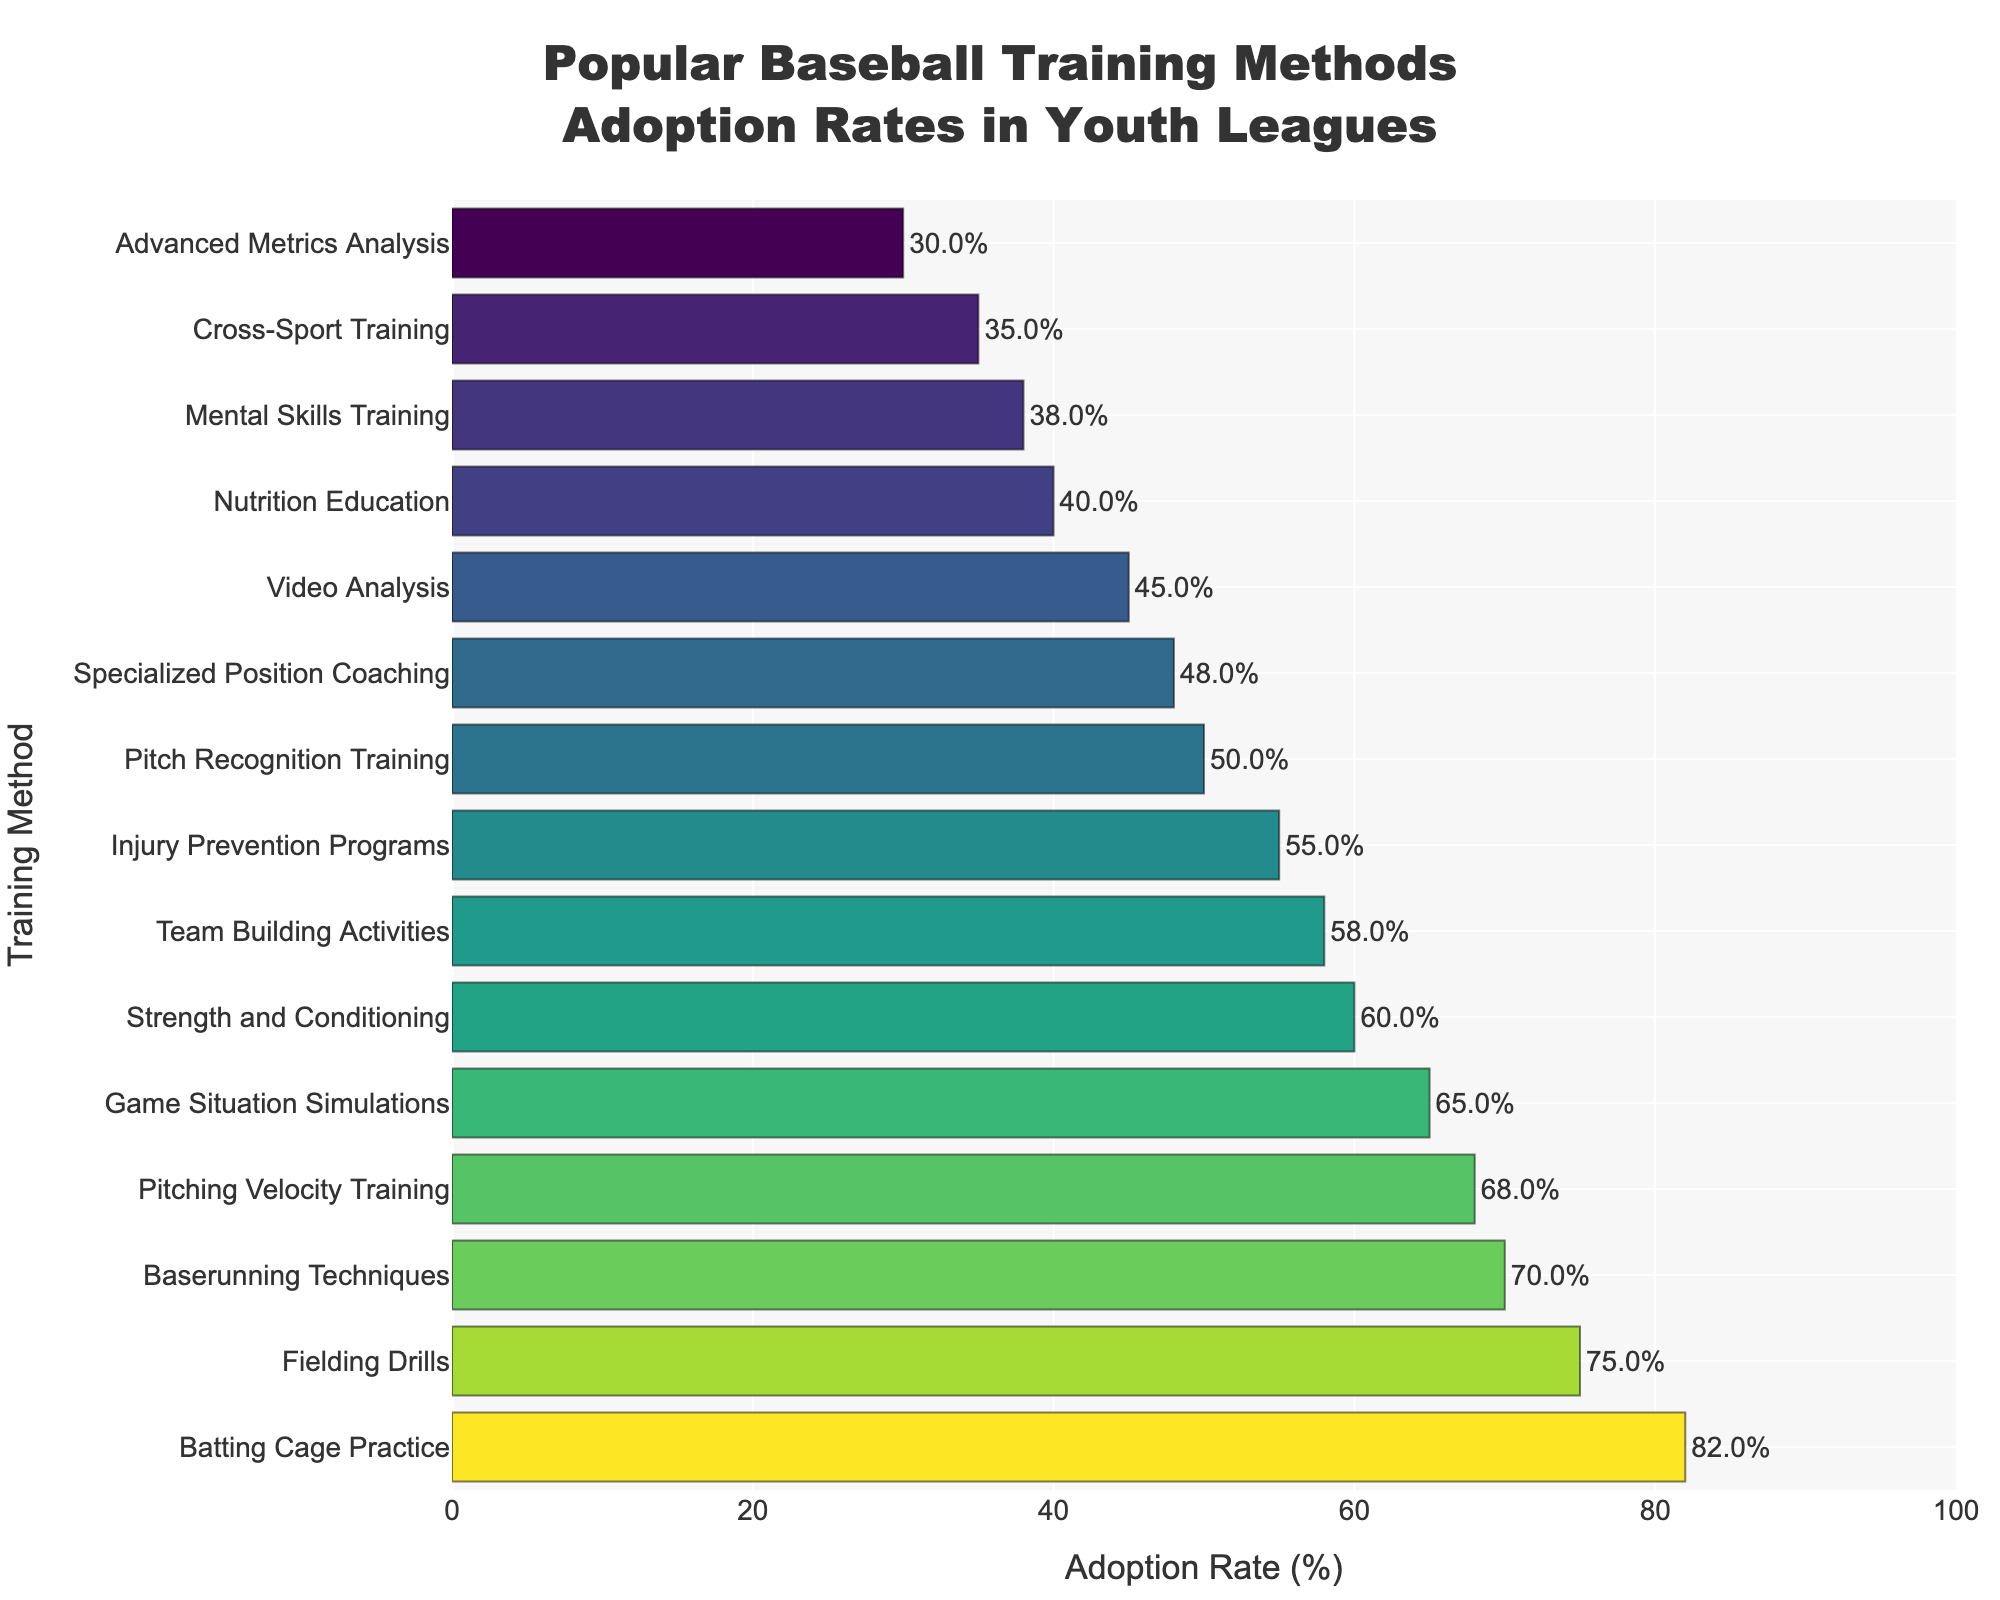Which training method has the highest adoption rate? The training method with the highest adoption rate is the one with the longest bar in the figure. Identify the training method on the y-axis with the longest bar reaching 82%.
Answer: Batting Cage Practice What is the adoption rate difference between Batting Cage Practice and Advanced Metrics Analysis? First, find the adoption rate of Batting Cage Practice (82%) and then find the adoption rate of Advanced Metrics Analysis (30%). Calculate the difference by subtracting the smaller rate from the larger one, 82% - 30%.
Answer: 52% Which training method has the closest adoption rate to 50%? To find the training method closest to 50%, look at the bars in the figure that are near the 50% mark and identify the associated training method.
Answer: Pitch Recognition Training How many training methods have an adoption rate above 60%? Identify the number of bars that exceed the 60% mark by observing the figure. Count each of these bars to get the total number. There are 6 such training methods.
Answer: 6 Which training methods have adoption rates between 40% and 60%? Find all the bars that fall between the 40% and 60% range by checking the figure, then list the associated training methods.
Answer: Nutrition Education, Pitch Recognition Training, Specialized Position Coaching, Injury Prevention Programs, Team Building Activities What is the average adoption rate of the top 3 training methods? Identify the top 3 training methods by their adoption rates: Batting Cage Practice (82%), Fielding Drills (75%), and Baserunning Techniques (70%). Calculate the average (82% + 75% + 70%)/3.
Answer: 75.67% Which training method has a higher adoption rate: Injury Prevention Programs or Nutrition Education? Compare the adoption rates of Injury Prevention Programs (55%) and Nutrition Education (40%). The higher value indicates the training method with a higher adoption rate.
Answer: Injury Prevention Programs What is the combined adoption rate of Game Situation Simulations and Cross-Sport Training? Find the adoption rates for Game Situation Simulations (65%) and Cross-Sport Training (35%). Add these two rates together to find the combined adoption rate, 65% + 35%.
Answer: 100% Which training method has an adoption rate that is exactly twice that of Advanced Metrics Analysis? Identify the adoption rate for Advanced Metrics Analysis (30%). Look for a training method with 60%, which is twice 30%.
Answer: Strength and Conditioning Which training method has a lower adoption rate: Video Analysis or Mental Skills Training? Compare the adoption rates for Video Analysis (45%) and Mental Skills Training (38%). The lower rate is for the training method with the lower adoption rate.
Answer: Mental Skills Training 